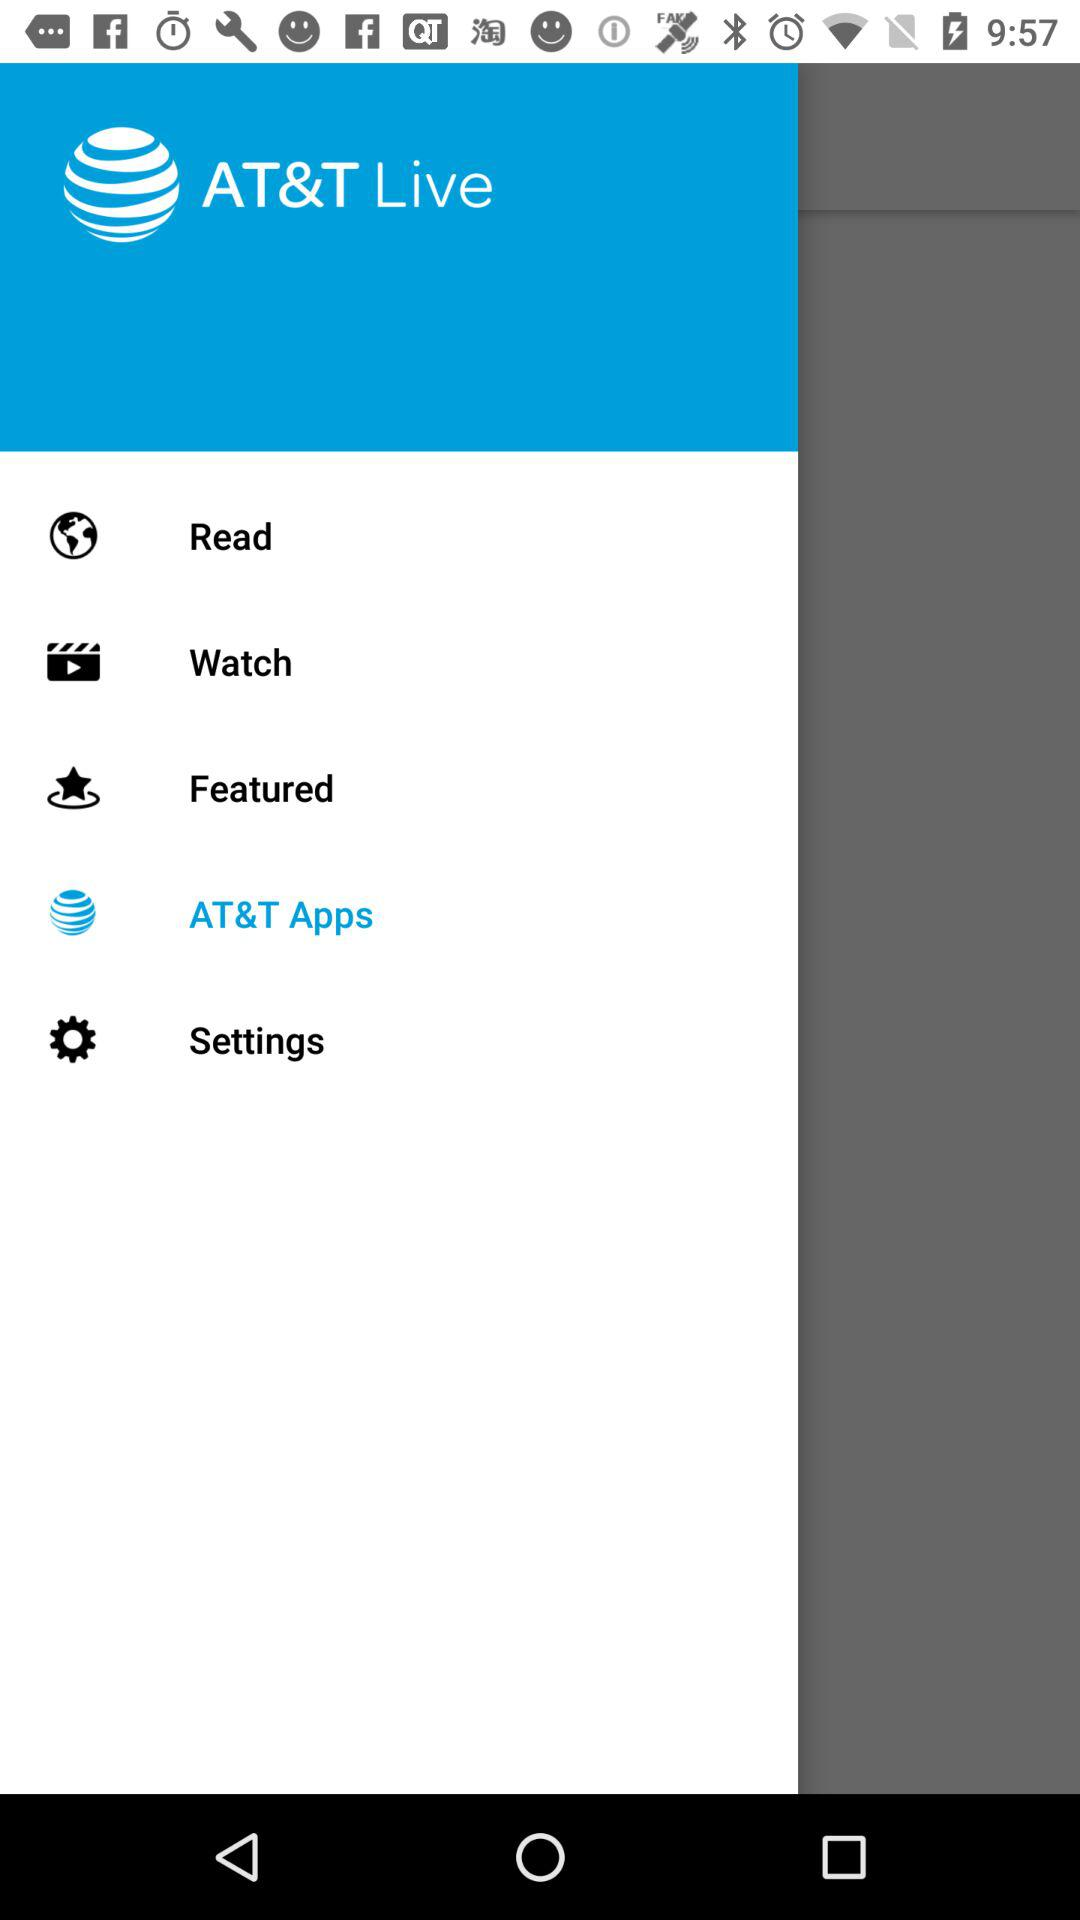What are the featured items?
When the provided information is insufficient, respond with <no answer>. <no answer> 